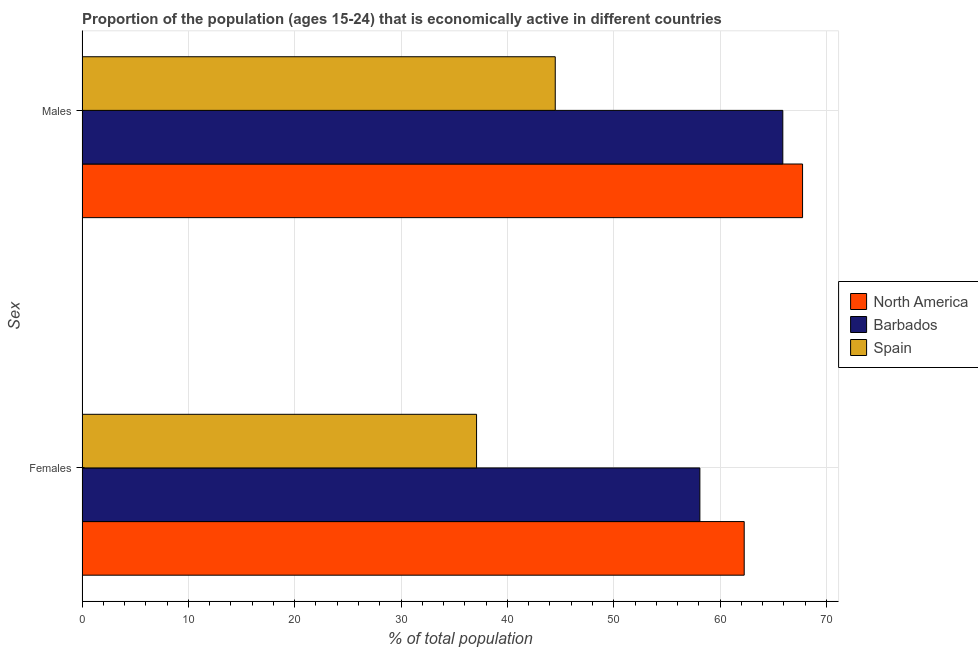How many groups of bars are there?
Provide a short and direct response. 2. Are the number of bars per tick equal to the number of legend labels?
Your answer should be compact. Yes. Are the number of bars on each tick of the Y-axis equal?
Your answer should be compact. Yes. What is the label of the 2nd group of bars from the top?
Give a very brief answer. Females. What is the percentage of economically active female population in Spain?
Offer a very short reply. 37.1. Across all countries, what is the maximum percentage of economically active female population?
Give a very brief answer. 62.27. Across all countries, what is the minimum percentage of economically active female population?
Offer a terse response. 37.1. In which country was the percentage of economically active male population maximum?
Ensure brevity in your answer.  North America. In which country was the percentage of economically active female population minimum?
Ensure brevity in your answer.  Spain. What is the total percentage of economically active female population in the graph?
Your answer should be very brief. 157.47. What is the difference between the percentage of economically active female population in Spain and that in North America?
Make the answer very short. -25.17. What is the difference between the percentage of economically active male population in North America and the percentage of economically active female population in Spain?
Your answer should be very brief. 30.66. What is the average percentage of economically active female population per country?
Keep it short and to the point. 52.49. What is the difference between the percentage of economically active male population and percentage of economically active female population in North America?
Your answer should be very brief. 5.49. In how many countries, is the percentage of economically active male population greater than 40 %?
Give a very brief answer. 3. What is the ratio of the percentage of economically active male population in Spain to that in North America?
Offer a very short reply. 0.66. Is the percentage of economically active male population in North America less than that in Barbados?
Make the answer very short. No. What does the 3rd bar from the top in Females represents?
Your response must be concise. North America. What does the 1st bar from the bottom in Females represents?
Provide a succinct answer. North America. Does the graph contain grids?
Make the answer very short. Yes. What is the title of the graph?
Give a very brief answer. Proportion of the population (ages 15-24) that is economically active in different countries. What is the label or title of the X-axis?
Provide a short and direct response. % of total population. What is the label or title of the Y-axis?
Offer a very short reply. Sex. What is the % of total population of North America in Females?
Provide a short and direct response. 62.27. What is the % of total population in Barbados in Females?
Offer a terse response. 58.1. What is the % of total population in Spain in Females?
Your response must be concise. 37.1. What is the % of total population in North America in Males?
Offer a very short reply. 67.76. What is the % of total population of Barbados in Males?
Give a very brief answer. 65.9. What is the % of total population in Spain in Males?
Offer a terse response. 44.5. Across all Sex, what is the maximum % of total population of North America?
Provide a succinct answer. 67.76. Across all Sex, what is the maximum % of total population of Barbados?
Your answer should be very brief. 65.9. Across all Sex, what is the maximum % of total population in Spain?
Your answer should be very brief. 44.5. Across all Sex, what is the minimum % of total population in North America?
Make the answer very short. 62.27. Across all Sex, what is the minimum % of total population in Barbados?
Make the answer very short. 58.1. Across all Sex, what is the minimum % of total population of Spain?
Provide a short and direct response. 37.1. What is the total % of total population of North America in the graph?
Offer a very short reply. 130.03. What is the total % of total population in Barbados in the graph?
Your answer should be very brief. 124. What is the total % of total population in Spain in the graph?
Your answer should be compact. 81.6. What is the difference between the % of total population of North America in Females and that in Males?
Your answer should be very brief. -5.49. What is the difference between the % of total population of Spain in Females and that in Males?
Offer a terse response. -7.4. What is the difference between the % of total population in North America in Females and the % of total population in Barbados in Males?
Offer a very short reply. -3.63. What is the difference between the % of total population of North America in Females and the % of total population of Spain in Males?
Your response must be concise. 17.77. What is the average % of total population in North America per Sex?
Your response must be concise. 65.01. What is the average % of total population of Barbados per Sex?
Keep it short and to the point. 62. What is the average % of total population in Spain per Sex?
Offer a very short reply. 40.8. What is the difference between the % of total population of North America and % of total population of Barbados in Females?
Make the answer very short. 4.17. What is the difference between the % of total population of North America and % of total population of Spain in Females?
Provide a short and direct response. 25.17. What is the difference between the % of total population in North America and % of total population in Barbados in Males?
Give a very brief answer. 1.86. What is the difference between the % of total population in North America and % of total population in Spain in Males?
Give a very brief answer. 23.26. What is the difference between the % of total population of Barbados and % of total population of Spain in Males?
Offer a terse response. 21.4. What is the ratio of the % of total population of North America in Females to that in Males?
Give a very brief answer. 0.92. What is the ratio of the % of total population in Barbados in Females to that in Males?
Your answer should be compact. 0.88. What is the ratio of the % of total population of Spain in Females to that in Males?
Your answer should be compact. 0.83. What is the difference between the highest and the second highest % of total population of North America?
Provide a succinct answer. 5.49. What is the difference between the highest and the second highest % of total population in Barbados?
Offer a terse response. 7.8. What is the difference between the highest and the second highest % of total population of Spain?
Ensure brevity in your answer.  7.4. What is the difference between the highest and the lowest % of total population in North America?
Ensure brevity in your answer.  5.49. What is the difference between the highest and the lowest % of total population in Barbados?
Offer a terse response. 7.8. 